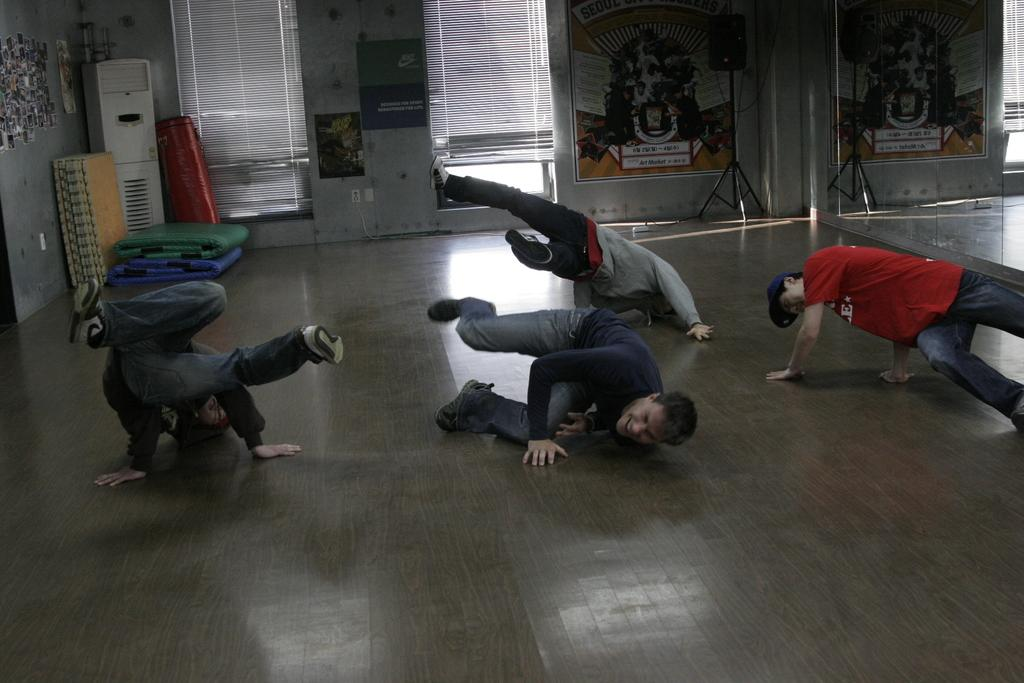What are the people in the image doing? The people in the image are dancing. What is visible beneath the people's feet in the image? There is a ground visible in the image. What object can be seen on the ground near the people? There is a speaker on the ground. What type of surface is provided for the dancers in the image? There are mats on the ground for the dancers. What is used to store cold items in the image? There is a cooler on the ground. What is on the wall in the image? There is a wall with posters in the image. What can be used for reflection in the image? There are mirrors on the wall. What type of humor can be seen in the image? There is no humor depicted in the image; it shows people dancing. Is there a tiger present in the image? No, there is no tiger present in the image. 